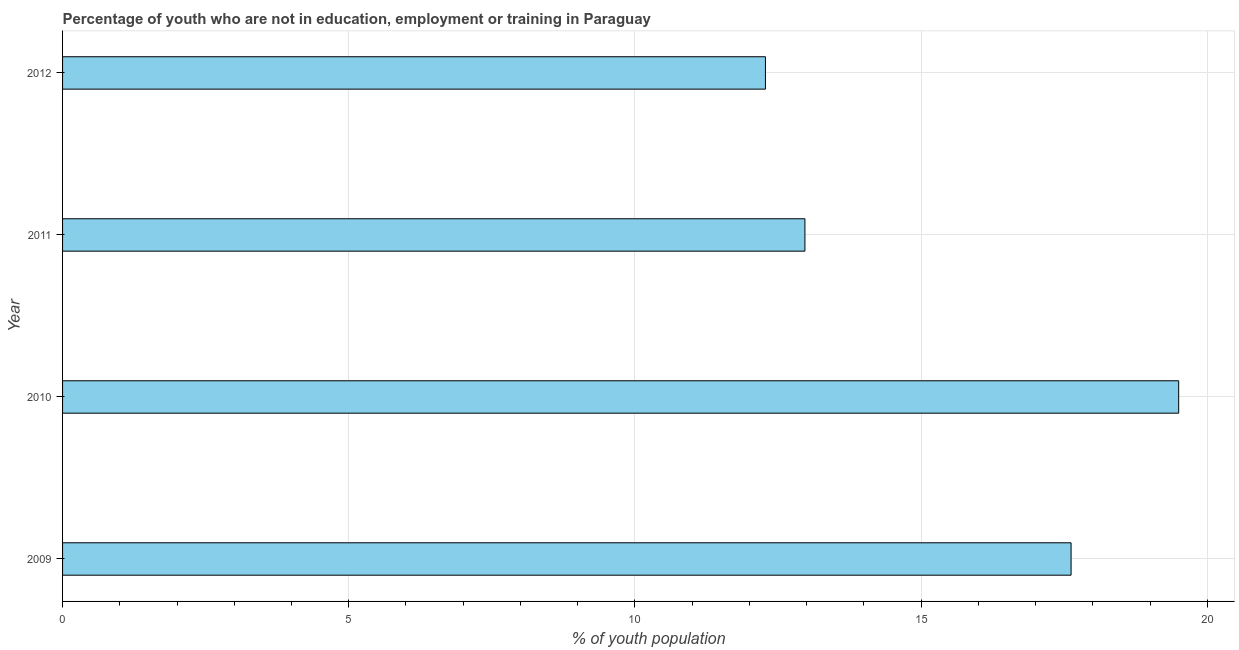What is the title of the graph?
Your answer should be very brief. Percentage of youth who are not in education, employment or training in Paraguay. What is the label or title of the X-axis?
Your response must be concise. % of youth population. What is the label or title of the Y-axis?
Keep it short and to the point. Year. What is the unemployed youth population in 2009?
Provide a short and direct response. 17.62. Across all years, what is the maximum unemployed youth population?
Give a very brief answer. 19.5. Across all years, what is the minimum unemployed youth population?
Provide a short and direct response. 12.28. What is the sum of the unemployed youth population?
Your answer should be very brief. 62.37. What is the difference between the unemployed youth population in 2009 and 2011?
Give a very brief answer. 4.65. What is the average unemployed youth population per year?
Your answer should be compact. 15.59. What is the median unemployed youth population?
Your response must be concise. 15.3. In how many years, is the unemployed youth population greater than 19 %?
Offer a terse response. 1. Do a majority of the years between 2010 and 2012 (inclusive) have unemployed youth population greater than 15 %?
Provide a short and direct response. No. What is the ratio of the unemployed youth population in 2009 to that in 2012?
Your answer should be compact. 1.44. What is the difference between the highest and the second highest unemployed youth population?
Provide a short and direct response. 1.88. Is the sum of the unemployed youth population in 2009 and 2011 greater than the maximum unemployed youth population across all years?
Your response must be concise. Yes. What is the difference between the highest and the lowest unemployed youth population?
Your answer should be compact. 7.22. In how many years, is the unemployed youth population greater than the average unemployed youth population taken over all years?
Offer a very short reply. 2. Are all the bars in the graph horizontal?
Ensure brevity in your answer.  Yes. How many years are there in the graph?
Ensure brevity in your answer.  4. What is the difference between two consecutive major ticks on the X-axis?
Provide a succinct answer. 5. Are the values on the major ticks of X-axis written in scientific E-notation?
Your answer should be compact. No. What is the % of youth population of 2009?
Make the answer very short. 17.62. What is the % of youth population in 2010?
Give a very brief answer. 19.5. What is the % of youth population of 2011?
Provide a succinct answer. 12.97. What is the % of youth population of 2012?
Your answer should be very brief. 12.28. What is the difference between the % of youth population in 2009 and 2010?
Provide a short and direct response. -1.88. What is the difference between the % of youth population in 2009 and 2011?
Your answer should be very brief. 4.65. What is the difference between the % of youth population in 2009 and 2012?
Provide a succinct answer. 5.34. What is the difference between the % of youth population in 2010 and 2011?
Offer a very short reply. 6.53. What is the difference between the % of youth population in 2010 and 2012?
Give a very brief answer. 7.22. What is the difference between the % of youth population in 2011 and 2012?
Offer a terse response. 0.69. What is the ratio of the % of youth population in 2009 to that in 2010?
Provide a succinct answer. 0.9. What is the ratio of the % of youth population in 2009 to that in 2011?
Make the answer very short. 1.36. What is the ratio of the % of youth population in 2009 to that in 2012?
Your response must be concise. 1.44. What is the ratio of the % of youth population in 2010 to that in 2011?
Make the answer very short. 1.5. What is the ratio of the % of youth population in 2010 to that in 2012?
Give a very brief answer. 1.59. What is the ratio of the % of youth population in 2011 to that in 2012?
Provide a short and direct response. 1.06. 